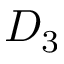Convert formula to latex. <formula><loc_0><loc_0><loc_500><loc_500>D _ { 3 }</formula> 